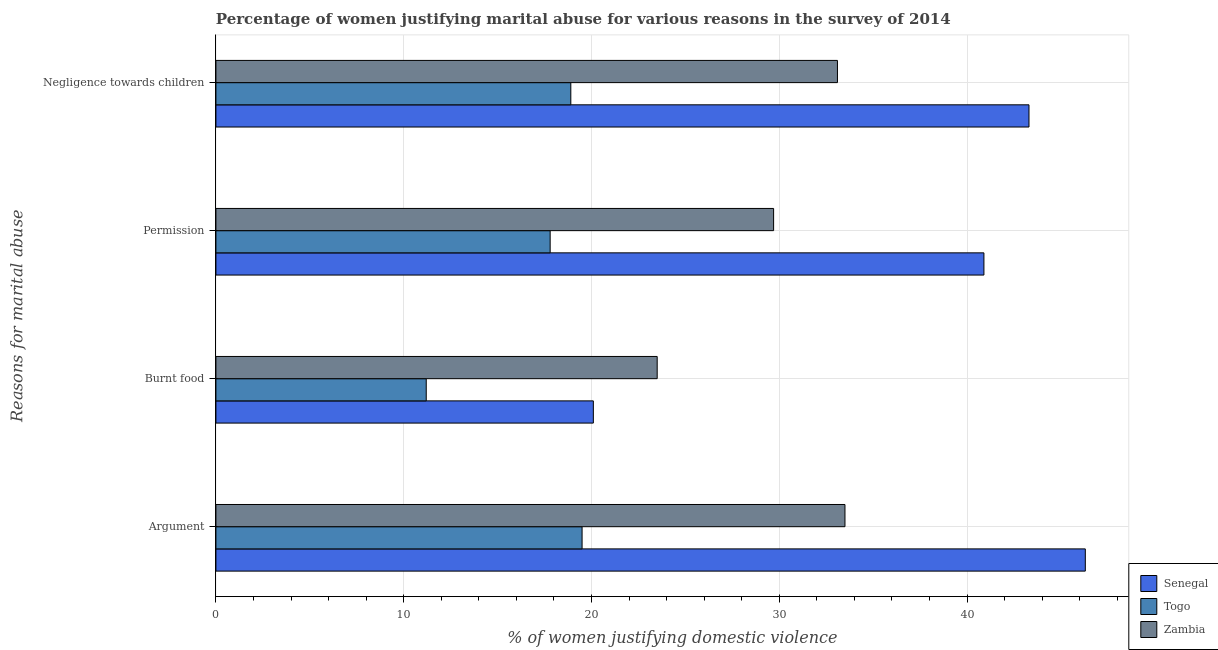Are the number of bars per tick equal to the number of legend labels?
Ensure brevity in your answer.  Yes. Are the number of bars on each tick of the Y-axis equal?
Keep it short and to the point. Yes. How many bars are there on the 4th tick from the top?
Your answer should be compact. 3. What is the label of the 4th group of bars from the top?
Ensure brevity in your answer.  Argument. Across all countries, what is the maximum percentage of women justifying abuse in the case of an argument?
Ensure brevity in your answer.  46.3. Across all countries, what is the minimum percentage of women justifying abuse for showing negligence towards children?
Offer a very short reply. 18.9. In which country was the percentage of women justifying abuse for burning food maximum?
Your answer should be very brief. Zambia. In which country was the percentage of women justifying abuse in the case of an argument minimum?
Ensure brevity in your answer.  Togo. What is the total percentage of women justifying abuse in the case of an argument in the graph?
Offer a terse response. 99.3. What is the difference between the percentage of women justifying abuse in the case of an argument in Senegal and that in Zambia?
Make the answer very short. 12.8. What is the difference between the percentage of women justifying abuse for burning food in Togo and the percentage of women justifying abuse in the case of an argument in Senegal?
Offer a terse response. -35.1. What is the average percentage of women justifying abuse for showing negligence towards children per country?
Ensure brevity in your answer.  31.77. What is the difference between the percentage of women justifying abuse for going without permission and percentage of women justifying abuse for burning food in Zambia?
Offer a terse response. 6.2. What is the ratio of the percentage of women justifying abuse for going without permission in Zambia to that in Togo?
Give a very brief answer. 1.67. Is the difference between the percentage of women justifying abuse for going without permission in Zambia and Togo greater than the difference between the percentage of women justifying abuse for burning food in Zambia and Togo?
Ensure brevity in your answer.  No. What is the difference between the highest and the second highest percentage of women justifying abuse for going without permission?
Your response must be concise. 11.2. Is it the case that in every country, the sum of the percentage of women justifying abuse for showing negligence towards children and percentage of women justifying abuse for going without permission is greater than the sum of percentage of women justifying abuse in the case of an argument and percentage of women justifying abuse for burning food?
Make the answer very short. Yes. What does the 3rd bar from the top in Burnt food represents?
Your answer should be compact. Senegal. What does the 3rd bar from the bottom in Argument represents?
Your response must be concise. Zambia. How many bars are there?
Provide a succinct answer. 12. Are all the bars in the graph horizontal?
Your answer should be very brief. Yes. What is the title of the graph?
Your answer should be very brief. Percentage of women justifying marital abuse for various reasons in the survey of 2014. Does "Malawi" appear as one of the legend labels in the graph?
Provide a short and direct response. No. What is the label or title of the X-axis?
Offer a terse response. % of women justifying domestic violence. What is the label or title of the Y-axis?
Offer a very short reply. Reasons for marital abuse. What is the % of women justifying domestic violence in Senegal in Argument?
Your answer should be compact. 46.3. What is the % of women justifying domestic violence of Togo in Argument?
Offer a terse response. 19.5. What is the % of women justifying domestic violence in Zambia in Argument?
Give a very brief answer. 33.5. What is the % of women justifying domestic violence in Senegal in Burnt food?
Offer a terse response. 20.1. What is the % of women justifying domestic violence in Togo in Burnt food?
Your answer should be very brief. 11.2. What is the % of women justifying domestic violence of Zambia in Burnt food?
Offer a terse response. 23.5. What is the % of women justifying domestic violence of Senegal in Permission?
Your answer should be very brief. 40.9. What is the % of women justifying domestic violence of Togo in Permission?
Ensure brevity in your answer.  17.8. What is the % of women justifying domestic violence in Zambia in Permission?
Offer a very short reply. 29.7. What is the % of women justifying domestic violence of Senegal in Negligence towards children?
Provide a succinct answer. 43.3. What is the % of women justifying domestic violence in Zambia in Negligence towards children?
Ensure brevity in your answer.  33.1. Across all Reasons for marital abuse, what is the maximum % of women justifying domestic violence of Senegal?
Ensure brevity in your answer.  46.3. Across all Reasons for marital abuse, what is the maximum % of women justifying domestic violence in Togo?
Provide a succinct answer. 19.5. Across all Reasons for marital abuse, what is the maximum % of women justifying domestic violence in Zambia?
Your answer should be very brief. 33.5. Across all Reasons for marital abuse, what is the minimum % of women justifying domestic violence in Senegal?
Your answer should be compact. 20.1. Across all Reasons for marital abuse, what is the minimum % of women justifying domestic violence in Togo?
Make the answer very short. 11.2. Across all Reasons for marital abuse, what is the minimum % of women justifying domestic violence of Zambia?
Offer a terse response. 23.5. What is the total % of women justifying domestic violence in Senegal in the graph?
Offer a very short reply. 150.6. What is the total % of women justifying domestic violence in Togo in the graph?
Make the answer very short. 67.4. What is the total % of women justifying domestic violence in Zambia in the graph?
Offer a terse response. 119.8. What is the difference between the % of women justifying domestic violence of Senegal in Argument and that in Burnt food?
Provide a short and direct response. 26.2. What is the difference between the % of women justifying domestic violence of Togo in Argument and that in Burnt food?
Make the answer very short. 8.3. What is the difference between the % of women justifying domestic violence in Zambia in Argument and that in Burnt food?
Your response must be concise. 10. What is the difference between the % of women justifying domestic violence in Togo in Argument and that in Permission?
Offer a very short reply. 1.7. What is the difference between the % of women justifying domestic violence of Senegal in Burnt food and that in Permission?
Ensure brevity in your answer.  -20.8. What is the difference between the % of women justifying domestic violence of Togo in Burnt food and that in Permission?
Provide a succinct answer. -6.6. What is the difference between the % of women justifying domestic violence in Zambia in Burnt food and that in Permission?
Provide a short and direct response. -6.2. What is the difference between the % of women justifying domestic violence of Senegal in Burnt food and that in Negligence towards children?
Keep it short and to the point. -23.2. What is the difference between the % of women justifying domestic violence in Togo in Burnt food and that in Negligence towards children?
Your answer should be very brief. -7.7. What is the difference between the % of women justifying domestic violence of Zambia in Burnt food and that in Negligence towards children?
Your response must be concise. -9.6. What is the difference between the % of women justifying domestic violence in Togo in Permission and that in Negligence towards children?
Provide a short and direct response. -1.1. What is the difference between the % of women justifying domestic violence in Zambia in Permission and that in Negligence towards children?
Provide a short and direct response. -3.4. What is the difference between the % of women justifying domestic violence in Senegal in Argument and the % of women justifying domestic violence in Togo in Burnt food?
Give a very brief answer. 35.1. What is the difference between the % of women justifying domestic violence of Senegal in Argument and the % of women justifying domestic violence of Zambia in Burnt food?
Ensure brevity in your answer.  22.8. What is the difference between the % of women justifying domestic violence in Togo in Argument and the % of women justifying domestic violence in Zambia in Burnt food?
Provide a short and direct response. -4. What is the difference between the % of women justifying domestic violence in Togo in Argument and the % of women justifying domestic violence in Zambia in Permission?
Your answer should be compact. -10.2. What is the difference between the % of women justifying domestic violence of Senegal in Argument and the % of women justifying domestic violence of Togo in Negligence towards children?
Offer a very short reply. 27.4. What is the difference between the % of women justifying domestic violence of Senegal in Burnt food and the % of women justifying domestic violence of Togo in Permission?
Provide a short and direct response. 2.3. What is the difference between the % of women justifying domestic violence in Togo in Burnt food and the % of women justifying domestic violence in Zambia in Permission?
Ensure brevity in your answer.  -18.5. What is the difference between the % of women justifying domestic violence in Senegal in Burnt food and the % of women justifying domestic violence in Togo in Negligence towards children?
Offer a very short reply. 1.2. What is the difference between the % of women justifying domestic violence of Senegal in Burnt food and the % of women justifying domestic violence of Zambia in Negligence towards children?
Make the answer very short. -13. What is the difference between the % of women justifying domestic violence of Togo in Burnt food and the % of women justifying domestic violence of Zambia in Negligence towards children?
Provide a short and direct response. -21.9. What is the difference between the % of women justifying domestic violence of Senegal in Permission and the % of women justifying domestic violence of Togo in Negligence towards children?
Ensure brevity in your answer.  22. What is the difference between the % of women justifying domestic violence of Togo in Permission and the % of women justifying domestic violence of Zambia in Negligence towards children?
Offer a terse response. -15.3. What is the average % of women justifying domestic violence of Senegal per Reasons for marital abuse?
Ensure brevity in your answer.  37.65. What is the average % of women justifying domestic violence of Togo per Reasons for marital abuse?
Your answer should be very brief. 16.85. What is the average % of women justifying domestic violence of Zambia per Reasons for marital abuse?
Your answer should be compact. 29.95. What is the difference between the % of women justifying domestic violence in Senegal and % of women justifying domestic violence in Togo in Argument?
Offer a terse response. 26.8. What is the difference between the % of women justifying domestic violence in Togo and % of women justifying domestic violence in Zambia in Argument?
Provide a succinct answer. -14. What is the difference between the % of women justifying domestic violence of Senegal and % of women justifying domestic violence of Togo in Burnt food?
Offer a terse response. 8.9. What is the difference between the % of women justifying domestic violence in Senegal and % of women justifying domestic violence in Zambia in Burnt food?
Make the answer very short. -3.4. What is the difference between the % of women justifying domestic violence in Senegal and % of women justifying domestic violence in Togo in Permission?
Your answer should be compact. 23.1. What is the difference between the % of women justifying domestic violence of Senegal and % of women justifying domestic violence of Togo in Negligence towards children?
Provide a succinct answer. 24.4. What is the difference between the % of women justifying domestic violence in Togo and % of women justifying domestic violence in Zambia in Negligence towards children?
Your answer should be very brief. -14.2. What is the ratio of the % of women justifying domestic violence of Senegal in Argument to that in Burnt food?
Offer a terse response. 2.3. What is the ratio of the % of women justifying domestic violence in Togo in Argument to that in Burnt food?
Offer a very short reply. 1.74. What is the ratio of the % of women justifying domestic violence in Zambia in Argument to that in Burnt food?
Your response must be concise. 1.43. What is the ratio of the % of women justifying domestic violence in Senegal in Argument to that in Permission?
Your answer should be compact. 1.13. What is the ratio of the % of women justifying domestic violence of Togo in Argument to that in Permission?
Your answer should be very brief. 1.1. What is the ratio of the % of women justifying domestic violence in Zambia in Argument to that in Permission?
Keep it short and to the point. 1.13. What is the ratio of the % of women justifying domestic violence of Senegal in Argument to that in Negligence towards children?
Offer a terse response. 1.07. What is the ratio of the % of women justifying domestic violence in Togo in Argument to that in Negligence towards children?
Give a very brief answer. 1.03. What is the ratio of the % of women justifying domestic violence in Zambia in Argument to that in Negligence towards children?
Your response must be concise. 1.01. What is the ratio of the % of women justifying domestic violence of Senegal in Burnt food to that in Permission?
Offer a terse response. 0.49. What is the ratio of the % of women justifying domestic violence in Togo in Burnt food to that in Permission?
Give a very brief answer. 0.63. What is the ratio of the % of women justifying domestic violence of Zambia in Burnt food to that in Permission?
Your answer should be compact. 0.79. What is the ratio of the % of women justifying domestic violence of Senegal in Burnt food to that in Negligence towards children?
Your answer should be very brief. 0.46. What is the ratio of the % of women justifying domestic violence of Togo in Burnt food to that in Negligence towards children?
Offer a terse response. 0.59. What is the ratio of the % of women justifying domestic violence of Zambia in Burnt food to that in Negligence towards children?
Keep it short and to the point. 0.71. What is the ratio of the % of women justifying domestic violence in Senegal in Permission to that in Negligence towards children?
Your answer should be very brief. 0.94. What is the ratio of the % of women justifying domestic violence in Togo in Permission to that in Negligence towards children?
Offer a very short reply. 0.94. What is the ratio of the % of women justifying domestic violence in Zambia in Permission to that in Negligence towards children?
Your answer should be very brief. 0.9. What is the difference between the highest and the second highest % of women justifying domestic violence of Senegal?
Your answer should be very brief. 3. What is the difference between the highest and the second highest % of women justifying domestic violence of Togo?
Provide a succinct answer. 0.6. What is the difference between the highest and the lowest % of women justifying domestic violence in Senegal?
Make the answer very short. 26.2. What is the difference between the highest and the lowest % of women justifying domestic violence of Togo?
Keep it short and to the point. 8.3. 